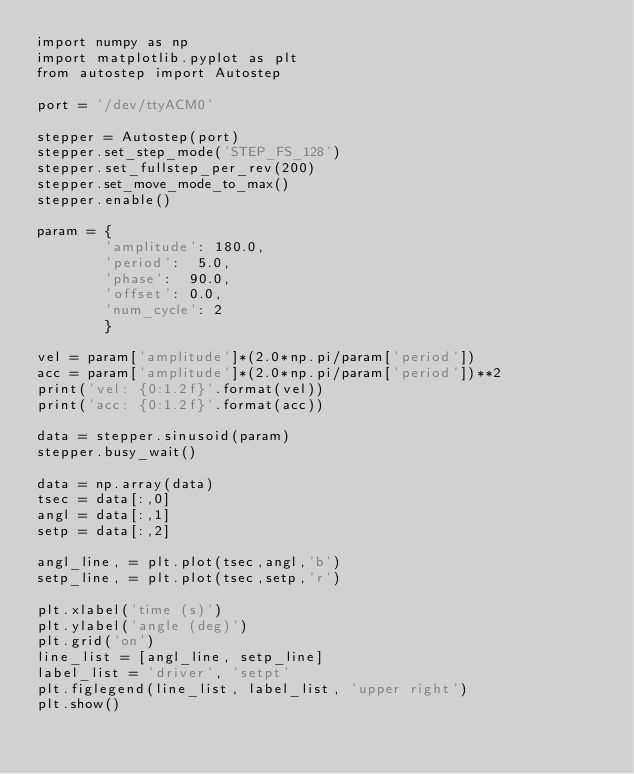<code> <loc_0><loc_0><loc_500><loc_500><_Python_>import numpy as np
import matplotlib.pyplot as plt
from autostep import Autostep

port = '/dev/ttyACM0'

stepper = Autostep(port)
stepper.set_step_mode('STEP_FS_128') 
stepper.set_fullstep_per_rev(200)
stepper.set_move_mode_to_max()
stepper.enable()

param = { 
        'amplitude': 180.0,
        'period':  5.0,
        'phase':  90.0,
        'offset': 0.0, 
        'num_cycle': 2 
        }

vel = param['amplitude']*(2.0*np.pi/param['period'])
acc = param['amplitude']*(2.0*np.pi/param['period'])**2
print('vel: {0:1.2f}'.format(vel))
print('acc: {0:1.2f}'.format(acc))

data = stepper.sinusoid(param)
stepper.busy_wait()

data = np.array(data)
tsec = data[:,0]
angl = data[:,1]
setp = data[:,2]

angl_line, = plt.plot(tsec,angl,'b')
setp_line, = plt.plot(tsec,setp,'r')

plt.xlabel('time (s)')
plt.ylabel('angle (deg)')
plt.grid('on')
line_list = [angl_line, setp_line]
label_list = 'driver', 'setpt'
plt.figlegend(line_list, label_list, 'upper right')
plt.show()
</code> 